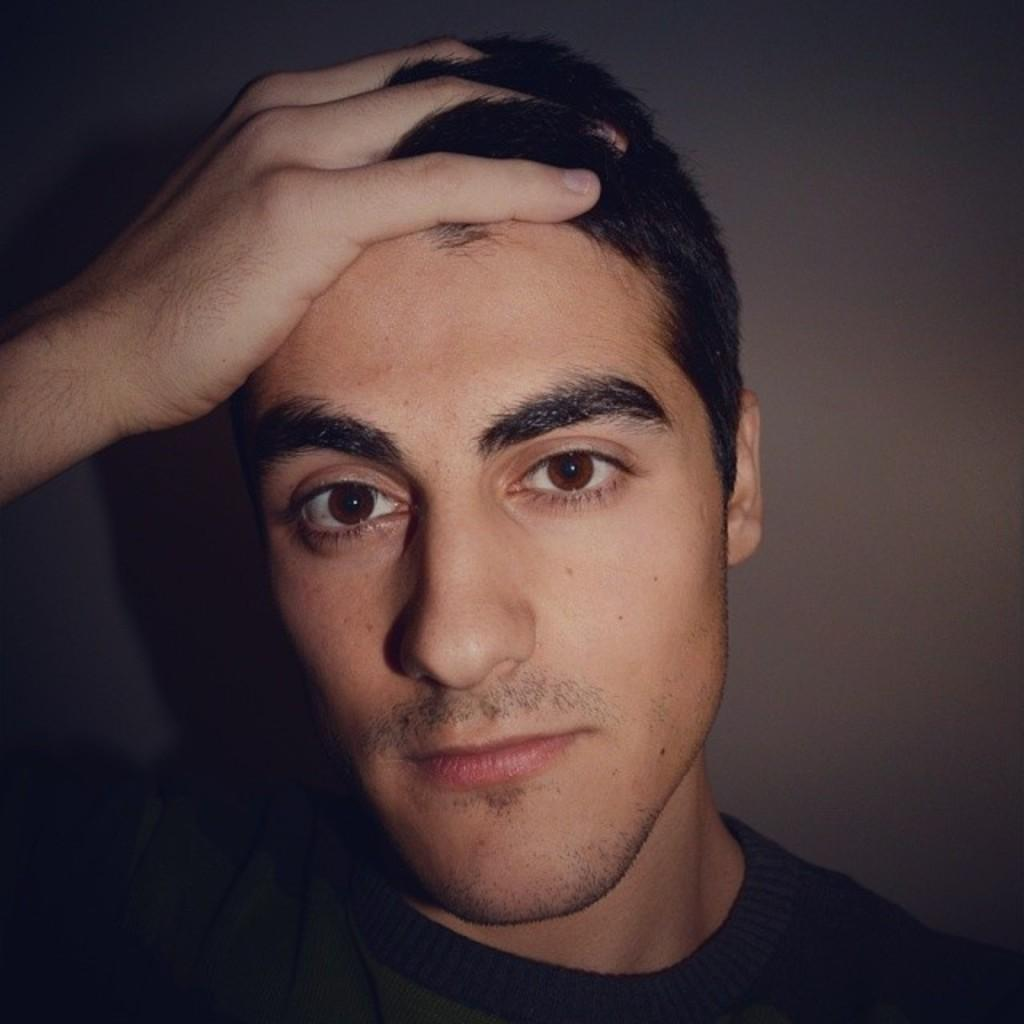What is the main subject of the image? The main subject of the image is a close-up of a man. What can be seen on the man in the image? The man is wearing clothes. How would you describe the lighting in the image? The corners of the image are dark. What type of tax is being discussed in the image? There is no discussion of tax in the image, as it is a close-up of a man wearing clothes. What shape is the silver object in the image? There is no silver object present in the image. 